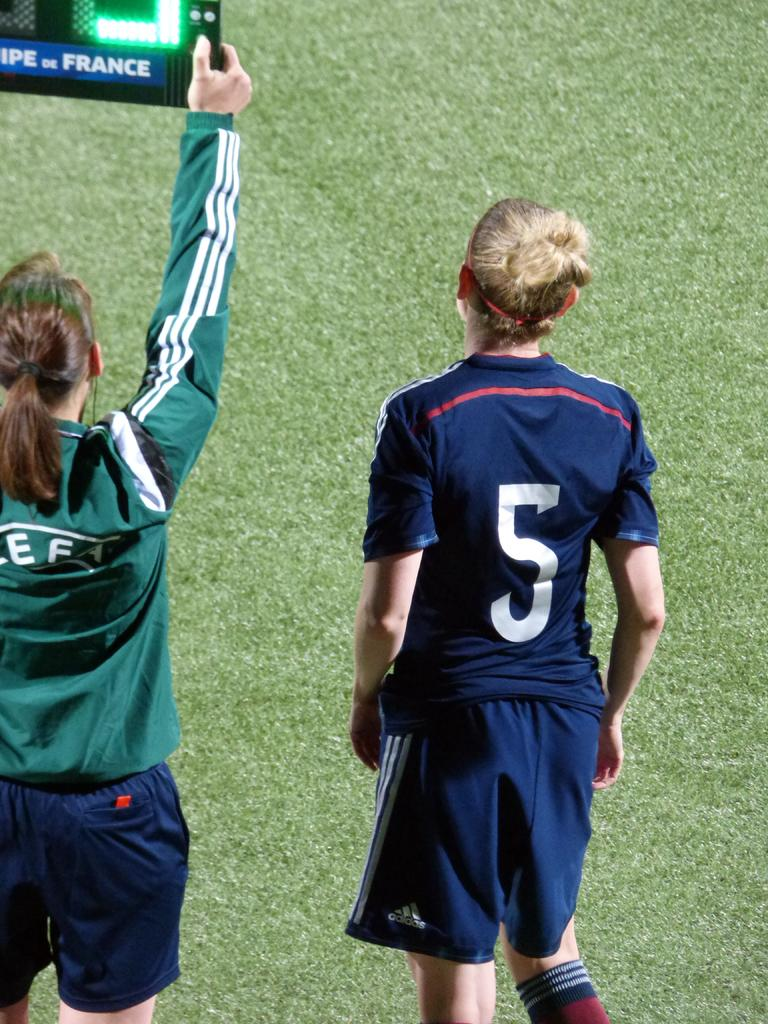<image>
Relay a brief, clear account of the picture shown. two players in teeshirts and shorts showing off a sign for france 